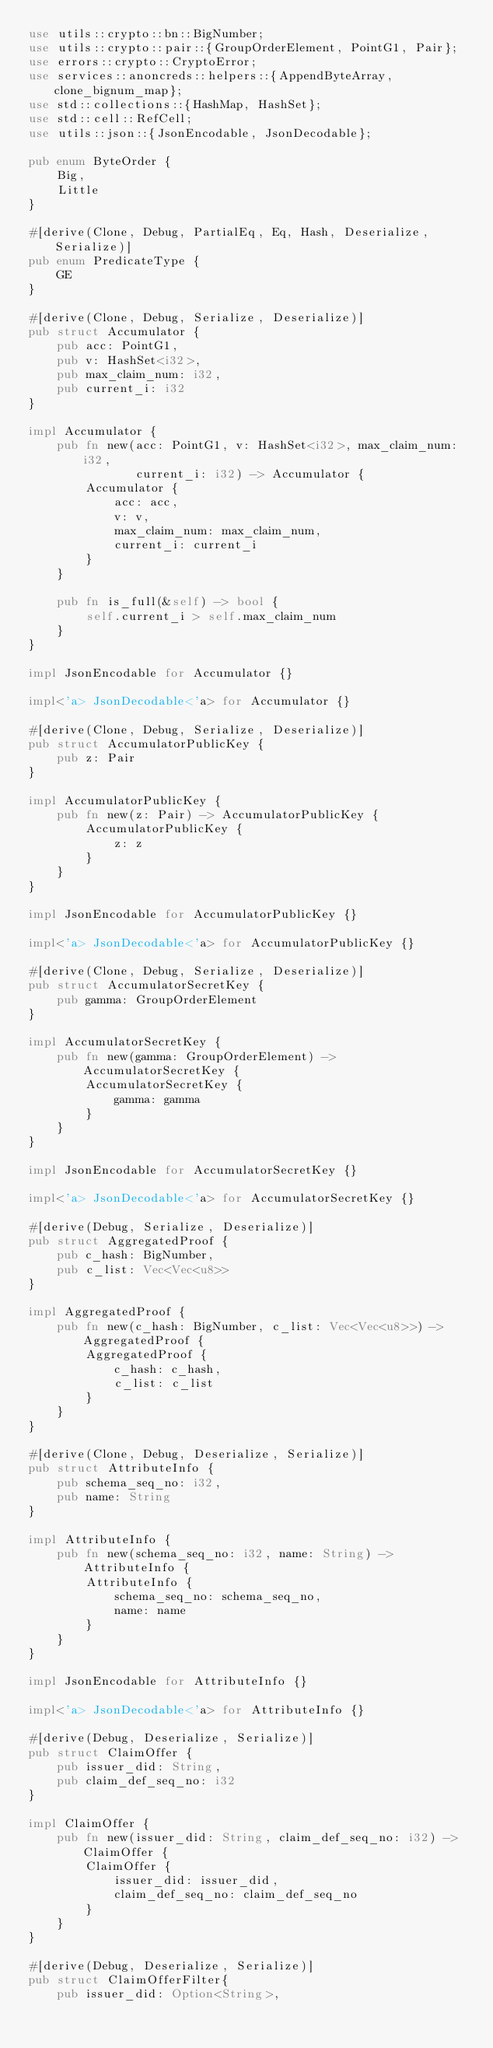Convert code to text. <code><loc_0><loc_0><loc_500><loc_500><_Rust_>use utils::crypto::bn::BigNumber;
use utils::crypto::pair::{GroupOrderElement, PointG1, Pair};
use errors::crypto::CryptoError;
use services::anoncreds::helpers::{AppendByteArray, clone_bignum_map};
use std::collections::{HashMap, HashSet};
use std::cell::RefCell;
use utils::json::{JsonEncodable, JsonDecodable};

pub enum ByteOrder {
    Big,
    Little
}

#[derive(Clone, Debug, PartialEq, Eq, Hash, Deserialize, Serialize)]
pub enum PredicateType {
    GE
}

#[derive(Clone, Debug, Serialize, Deserialize)]
pub struct Accumulator {
    pub acc: PointG1,
    pub v: HashSet<i32>,
    pub max_claim_num: i32,
    pub current_i: i32
}

impl Accumulator {
    pub fn new(acc: PointG1, v: HashSet<i32>, max_claim_num: i32,
               current_i: i32) -> Accumulator {
        Accumulator {
            acc: acc,
            v: v,
            max_claim_num: max_claim_num,
            current_i: current_i
        }
    }

    pub fn is_full(&self) -> bool {
        self.current_i > self.max_claim_num
    }
}

impl JsonEncodable for Accumulator {}

impl<'a> JsonDecodable<'a> for Accumulator {}

#[derive(Clone, Debug, Serialize, Deserialize)]
pub struct AccumulatorPublicKey {
    pub z: Pair
}

impl AccumulatorPublicKey {
    pub fn new(z: Pair) -> AccumulatorPublicKey {
        AccumulatorPublicKey {
            z: z
        }
    }
}

impl JsonEncodable for AccumulatorPublicKey {}

impl<'a> JsonDecodable<'a> for AccumulatorPublicKey {}

#[derive(Clone, Debug, Serialize, Deserialize)]
pub struct AccumulatorSecretKey {
    pub gamma: GroupOrderElement
}

impl AccumulatorSecretKey {
    pub fn new(gamma: GroupOrderElement) -> AccumulatorSecretKey {
        AccumulatorSecretKey {
            gamma: gamma
        }
    }
}

impl JsonEncodable for AccumulatorSecretKey {}

impl<'a> JsonDecodable<'a> for AccumulatorSecretKey {}

#[derive(Debug, Serialize, Deserialize)]
pub struct AggregatedProof {
    pub c_hash: BigNumber,
    pub c_list: Vec<Vec<u8>>
}

impl AggregatedProof {
    pub fn new(c_hash: BigNumber, c_list: Vec<Vec<u8>>) -> AggregatedProof {
        AggregatedProof {
            c_hash: c_hash,
            c_list: c_list
        }
    }
}

#[derive(Clone, Debug, Deserialize, Serialize)]
pub struct AttributeInfo {
    pub schema_seq_no: i32,
    pub name: String
}

impl AttributeInfo {
    pub fn new(schema_seq_no: i32, name: String) -> AttributeInfo {
        AttributeInfo {
            schema_seq_no: schema_seq_no,
            name: name
        }
    }
}

impl JsonEncodable for AttributeInfo {}

impl<'a> JsonDecodable<'a> for AttributeInfo {}

#[derive(Debug, Deserialize, Serialize)]
pub struct ClaimOffer {
    pub issuer_did: String,
    pub claim_def_seq_no: i32
}

impl ClaimOffer {
    pub fn new(issuer_did: String, claim_def_seq_no: i32) -> ClaimOffer {
        ClaimOffer {
            issuer_did: issuer_did,
            claim_def_seq_no: claim_def_seq_no
        }
    }
}

#[derive(Debug, Deserialize, Serialize)]
pub struct ClaimOfferFilter{
    pub issuer_did: Option<String>,</code> 